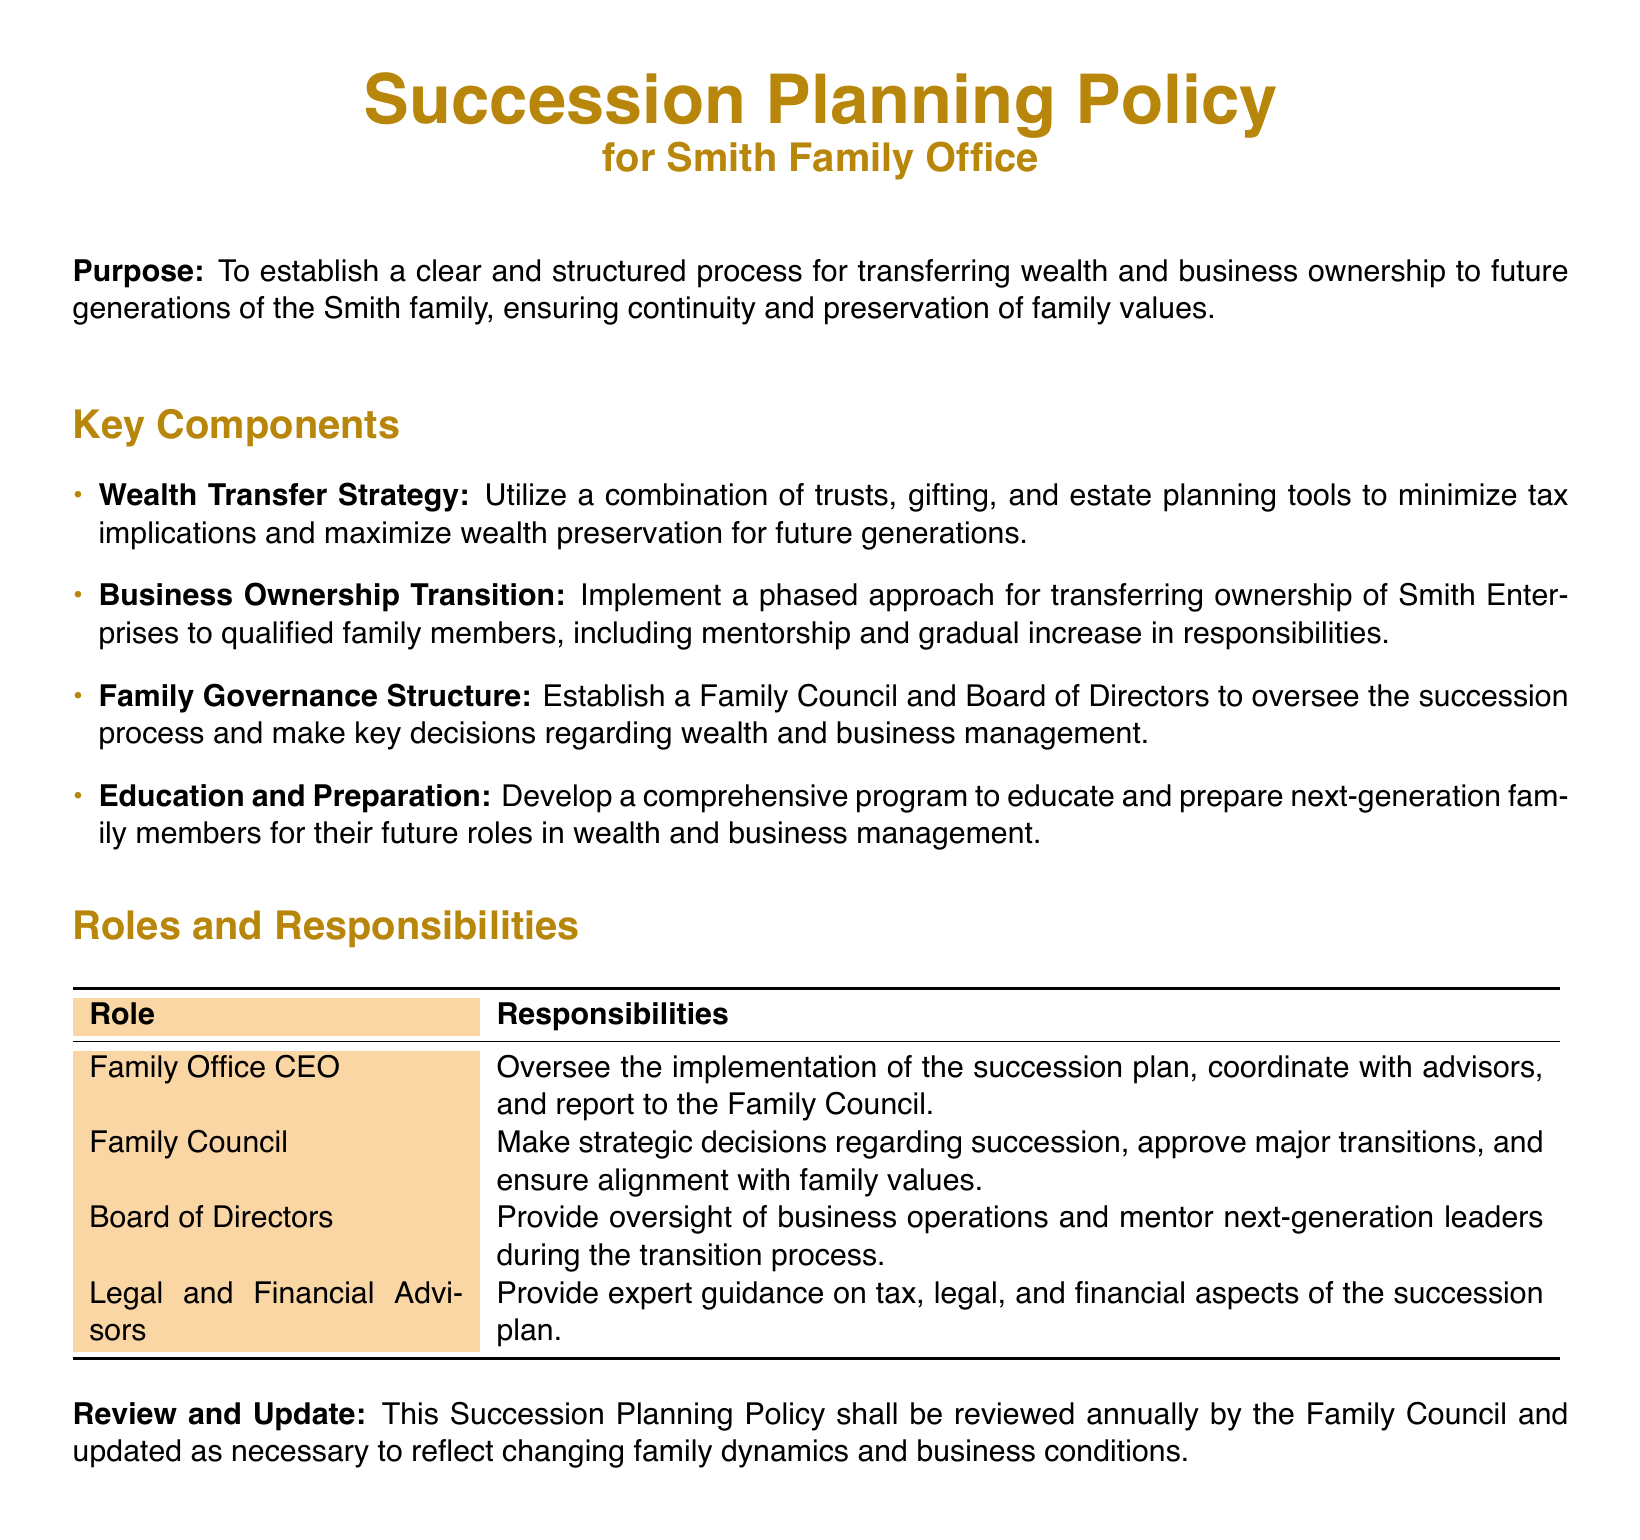What is the purpose of the Succession Planning Policy? The purpose outlines the aim of the policy, which is to establish a clear process for transferring wealth and business ownership to future generations.
Answer: To establish a clear and structured process for transferring wealth and business ownership to future generations of the Smith family, ensuring continuity and preservation of family values What combination of strategies is utilized for wealth transfer? The document specifies a combination of strategies to minimize tax implications and maximize wealth preservation.
Answer: Trusts, gifting, and estate planning tools What is the role of the Family Council? The Family Council is responsible for making strategic decisions regarding succession and ensuring alignment with family values.
Answer: Make strategic decisions regarding succession, approve major transitions, and ensure alignment with family values Who oversees the implementation of the succession plan? This role is assigned to a specific position mentioned in the document.
Answer: Family Office CEO How often is the Succession Planning Policy reviewed? The document states how frequently the policy should be reviewed to reflect changes.
Answer: Annually What is one key component of the Family Governance Structure? The document lists components that are part of the governance structure involved in succession planning.
Answer: Family Council and Board of Directors What is the objective of the education and preparation program? The purpose of this program is described in relation to the next generation's future roles.
Answer: To educate and prepare next-generation family members for their future roles in wealth and business management What is the responsibility of Legal and Financial Advisors? This specifies the type of guidance these advisors provide according to the document.
Answer: Provide expert guidance on tax, legal, and financial aspects of the succession plan 